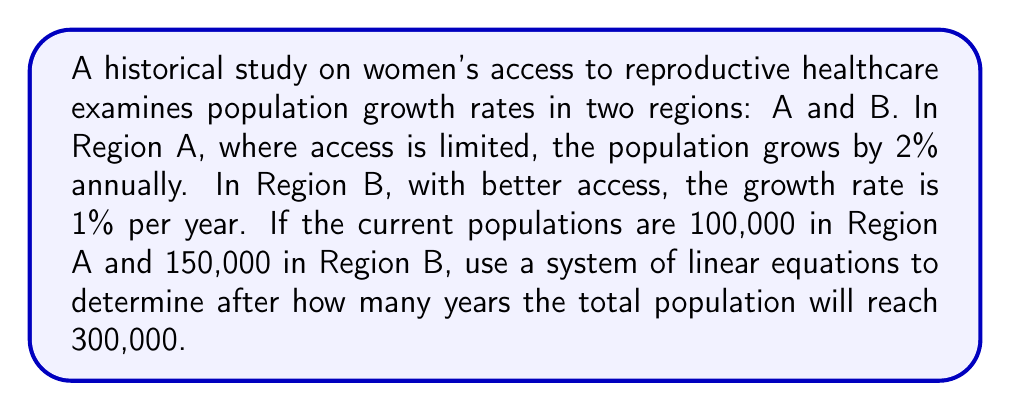Solve this math problem. Let's approach this step-by-step:

1) Let $x$ be the number of years. We need to set up equations for each region's population after $x$ years.

2) For Region A:
   Initial population = 100,000
   After $x$ years: $A(x) = 100,000(1.02)^x$

3) For Region B:
   Initial population = 150,000
   After $x$ years: $B(x) = 150,000(1.01)^x$

4) The total population after $x$ years should equal 300,000:

   $A(x) + B(x) = 300,000$

5) Substituting our equations:

   $100,000(1.02)^x + 150,000(1.01)^x = 300,000$

6) This is our system of linear equations, albeit with only one equation. To solve this, we need to use logarithms.

7) Dividing both sides by 100,000:

   $(1.02)^x + 1.5(1.01)^x = 3$

8) This equation can't be solved algebraically. We need to use numerical methods or graphing to find the solution.

9) Using a graphing calculator or computer software, we can find that $x \approx 5.4$ years.

10) Since we're dealing with whole years, we round up to 6 years.
Answer: 6 years 